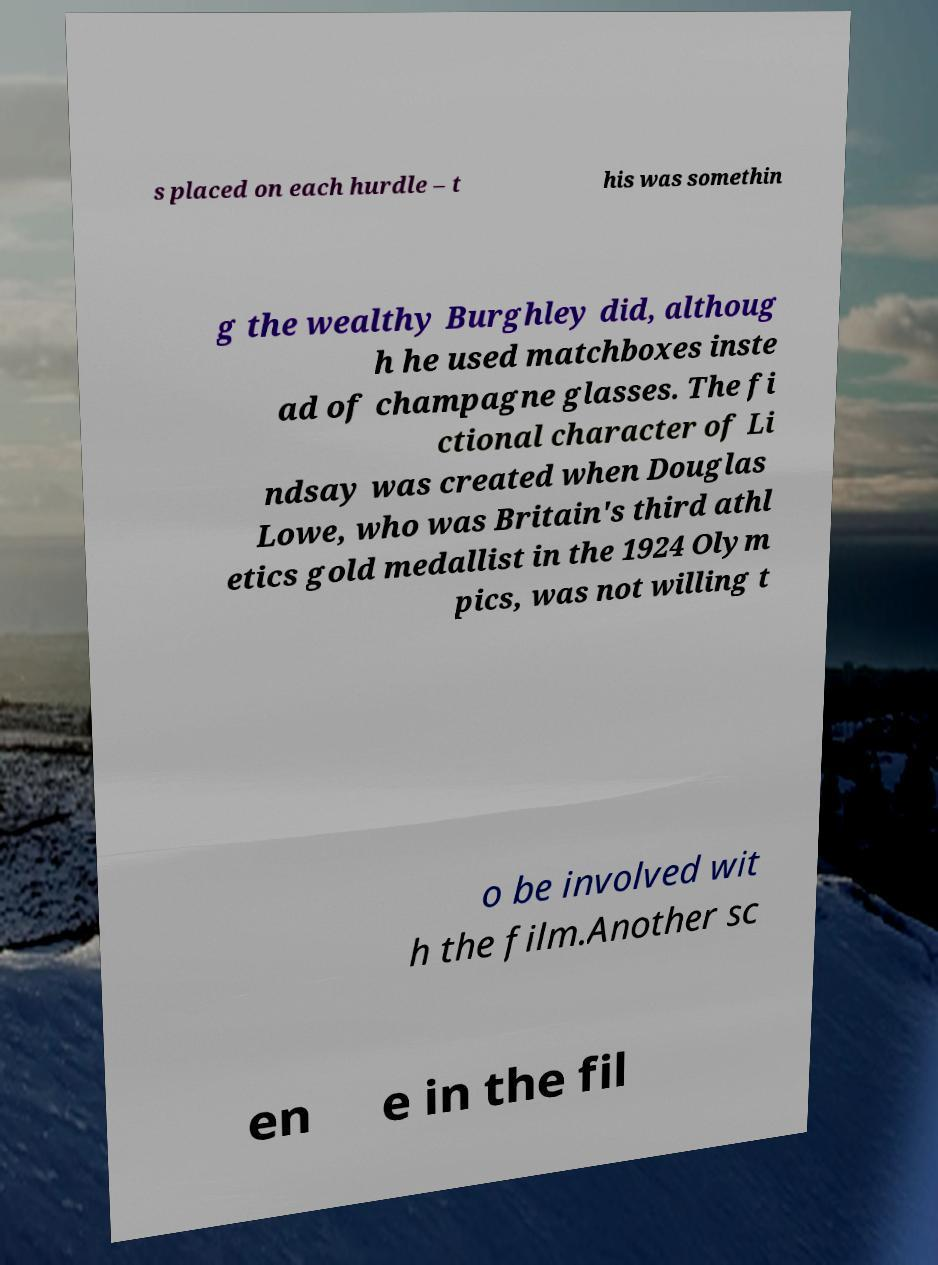Can you read and provide the text displayed in the image?This photo seems to have some interesting text. Can you extract and type it out for me? s placed on each hurdle – t his was somethin g the wealthy Burghley did, althoug h he used matchboxes inste ad of champagne glasses. The fi ctional character of Li ndsay was created when Douglas Lowe, who was Britain's third athl etics gold medallist in the 1924 Olym pics, was not willing t o be involved wit h the film.Another sc en e in the fil 